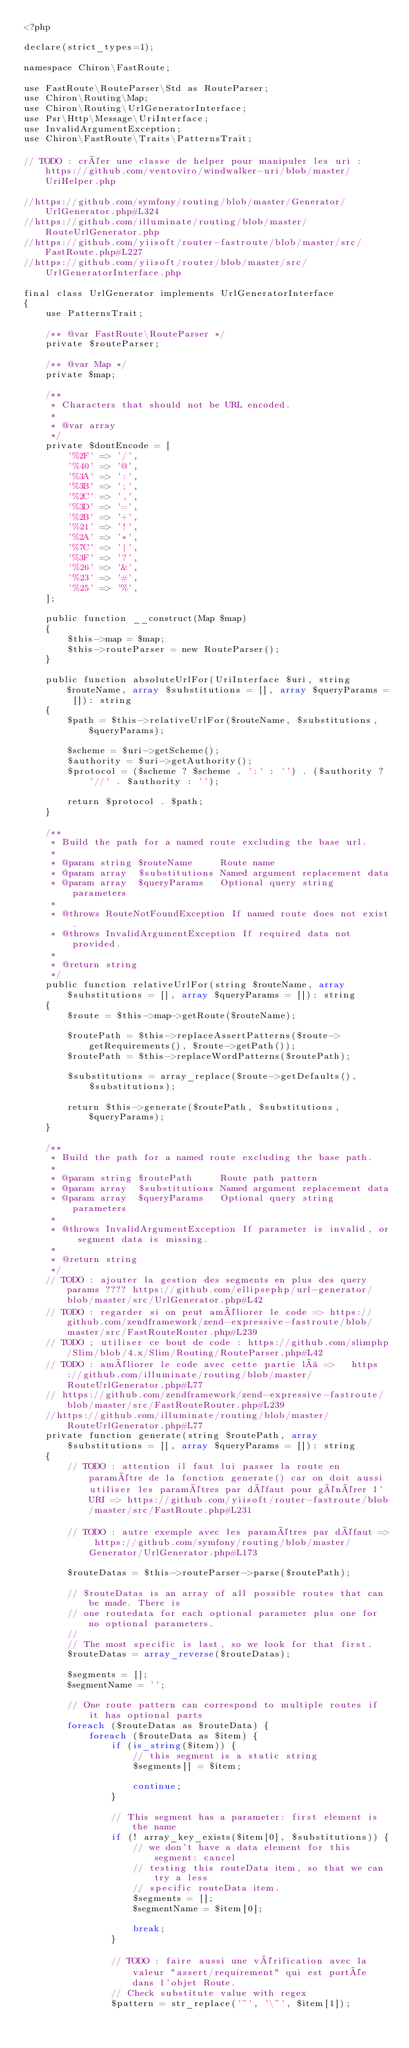Convert code to text. <code><loc_0><loc_0><loc_500><loc_500><_PHP_><?php

declare(strict_types=1);

namespace Chiron\FastRoute;

use FastRoute\RouteParser\Std as RouteParser;
use Chiron\Routing\Map;
use Chiron\Routing\UrlGeneratorInterface;
use Psr\Http\Message\UriInterface;
use InvalidArgumentException;
use Chiron\FastRoute\Traits\PatternsTrait;

// TODO : créer une classe de helper pour manipuler les uri :   https://github.com/ventoviro/windwalker-uri/blob/master/UriHelper.php

//https://github.com/symfony/routing/blob/master/Generator/UrlGenerator.php#L324
//https://github.com/illuminate/routing/blob/master/RouteUrlGenerator.php
//https://github.com/yiisoft/router-fastroute/blob/master/src/FastRoute.php#L227
//https://github.com/yiisoft/router/blob/master/src/UrlGeneratorInterface.php

final class UrlGenerator implements UrlGeneratorInterface
{
    use PatternsTrait;

    /** @var FastRoute\RouteParser */
    private $routeParser;

    /** @var Map */
    private $map;

    /**
     * Characters that should not be URL encoded.
     *
     * @var array
     */
    private $dontEncode = [
        '%2F' => '/',
        '%40' => '@',
        '%3A' => ':',
        '%3B' => ';',
        '%2C' => ',',
        '%3D' => '=',
        '%2B' => '+',
        '%21' => '!',
        '%2A' => '*',
        '%7C' => '|',
        '%3F' => '?',
        '%26' => '&',
        '%23' => '#',
        '%25' => '%',
    ];

    public function __construct(Map $map)
    {
        $this->map = $map;
        $this->routeParser = new RouteParser();
    }

    public function absoluteUrlFor(UriInterface $uri, string $routeName, array $substitutions = [], array $queryParams = []): string
    {
        $path = $this->relativeUrlFor($routeName, $substitutions, $queryParams);

        $scheme = $uri->getScheme();
        $authority = $uri->getAuthority();
        $protocol = ($scheme ? $scheme . ':' : '') . ($authority ? '//' . $authority : '');

        return $protocol . $path;
    }

    /**
     * Build the path for a named route excluding the base url.
     *
     * @param string $routeName     Route name
     * @param array  $substitutions Named argument replacement data
     * @param array  $queryParams   Optional query string parameters
     *
     * @throws RouteNotFoundException If named route does not exist.
     * @throws InvalidArgumentException If required data not provided.
     *
     * @return string
     */
    public function relativeUrlFor(string $routeName, array $substitutions = [], array $queryParams = []): string
    {
        $route = $this->map->getRoute($routeName);

        $routePath = $this->replaceAssertPatterns($route->getRequirements(), $route->getPath());
        $routePath = $this->replaceWordPatterns($routePath);

        $substitutions = array_replace($route->getDefaults(), $substitutions);

        return $this->generate($routePath, $substitutions, $queryParams);
    }

    /**
     * Build the path for a named route excluding the base path.
     *
     * @param string $routePath     Route path pattern
     * @param array  $substitutions Named argument replacement data
     * @param array  $queryParams   Optional query string parameters
     *
     * @throws InvalidArgumentException If parameter is invalid, or segment data is missing.
     *
     * @return string
     */
    // TODO : ajouter la gestion des segments en plus des query params ???? https://github.com/ellipsephp/url-generator/blob/master/src/UrlGenerator.php#L42
    // TODO : regarder si on peut améliorer le code => https://github.com/zendframework/zend-expressive-fastroute/blob/master/src/FastRouteRouter.php#L239
    // TODO ; utiliser ce bout de code : https://github.com/slimphp/Slim/blob/4.x/Slim/Routing/RouteParser.php#L42
    // TODO : améliorer le code avec cette partie là =>   https://github.com/illuminate/routing/blob/master/RouteUrlGenerator.php#L77
    // https://github.com/zendframework/zend-expressive-fastroute/blob/master/src/FastRouteRouter.php#L239
    //https://github.com/illuminate/routing/blob/master/RouteUrlGenerator.php#L77
    private function generate(string $routePath, array $substitutions = [], array $queryParams = []): string
    {
        // TODO : attention il faut lui passer la route en paramétre de la fonction generate() car on doit aussi utiliser les paramétres par défaut pour générer l'URI => https://github.com/yiisoft/router-fastroute/blob/master/src/FastRoute.php#L231

        // TODO : autre exemple avec les paramétres par défaut => https://github.com/symfony/routing/blob/master/Generator/UrlGenerator.php#L173

        $routeDatas = $this->routeParser->parse($routePath);

        // $routeDatas is an array of all possible routes that can be made. There is
        // one routedata for each optional parameter plus one for no optional parameters.
        //
        // The most specific is last, so we look for that first.
        $routeDatas = array_reverse($routeDatas);

        $segments = [];
        $segmentName = '';

        // One route pattern can correspond to multiple routes if it has optional parts
        foreach ($routeDatas as $routeData) {
            foreach ($routeData as $item) {
                if (is_string($item)) {
                    // this segment is a static string
                    $segments[] = $item;

                    continue;
                }

                // This segment has a parameter: first element is the name
                if (! array_key_exists($item[0], $substitutions)) {
                    // we don't have a data element for this segment: cancel
                    // testing this routeData item, so that we can try a less
                    // specific routeData item.
                    $segments = [];
                    $segmentName = $item[0];

                    break;
                }

                // TODO : faire aussi une vérification avec la valeur "assert/requirement" qui est portée dans l'objet Route.
                // Check substitute value with regex
                $pattern = str_replace('~', '\~', $item[1]);</code> 